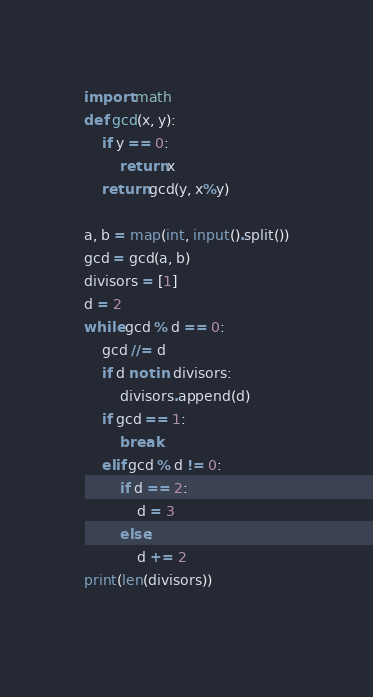<code> <loc_0><loc_0><loc_500><loc_500><_Python_>import math
def gcd(x, y):
    if y == 0:
        return x
    return gcd(y, x%y)

a, b = map(int, input().split())
gcd = gcd(a, b)
divisors = [1]
d = 2
while gcd % d == 0:
    gcd //= d
    if d not in divisors:
        divisors.append(d)
    if gcd == 1:
        break
    elif gcd % d != 0:
        if d == 2:
            d = 3
        else:
            d += 2
print(len(divisors))
    </code> 